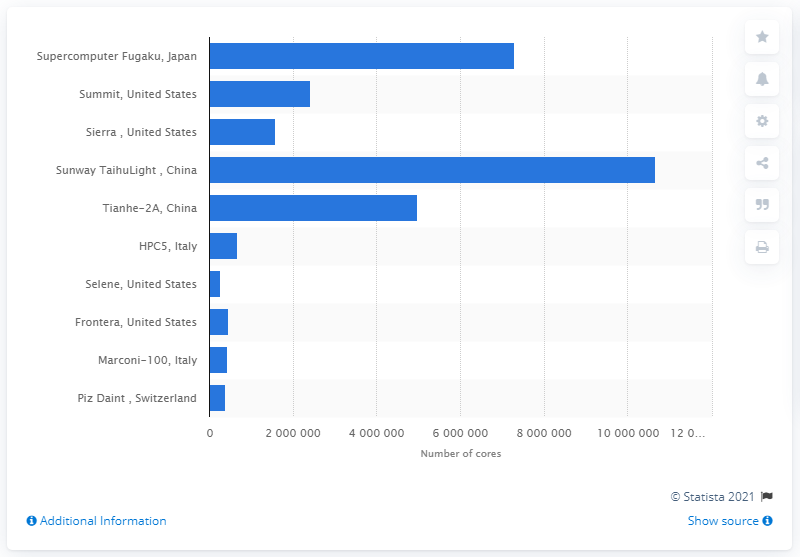Outline some significant characteristics in this image. The supercomputer Fugaku had 729,907,296 cores. 